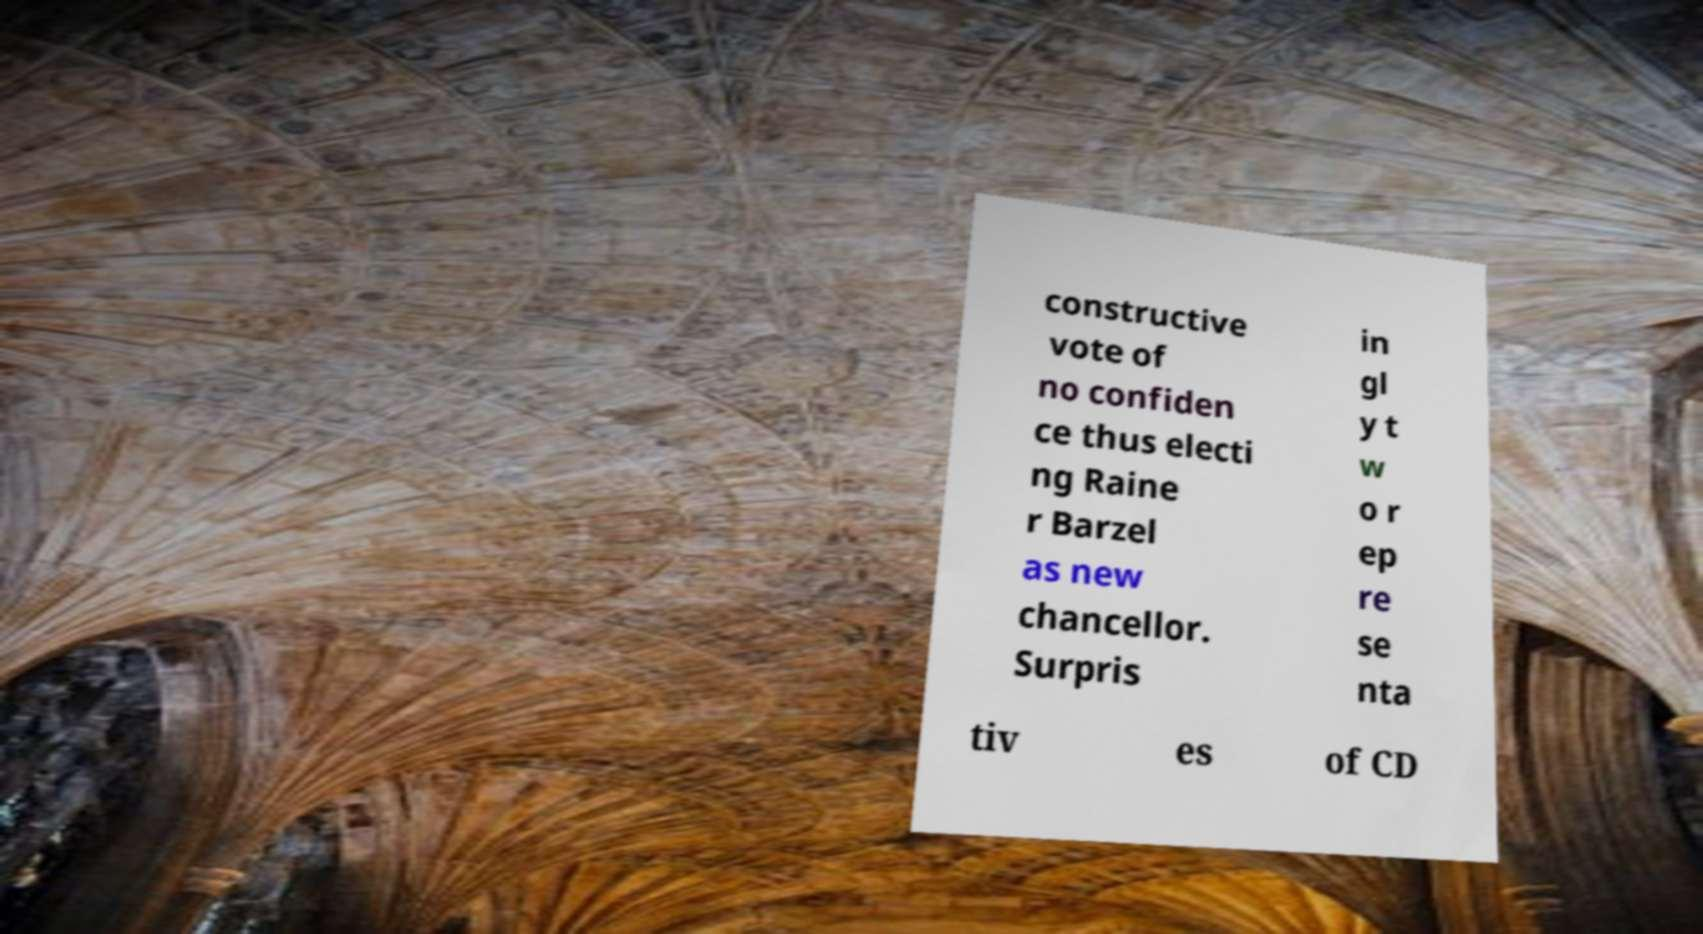What messages or text are displayed in this image? I need them in a readable, typed format. constructive vote of no confiden ce thus electi ng Raine r Barzel as new chancellor. Surpris in gl y t w o r ep re se nta tiv es of CD 